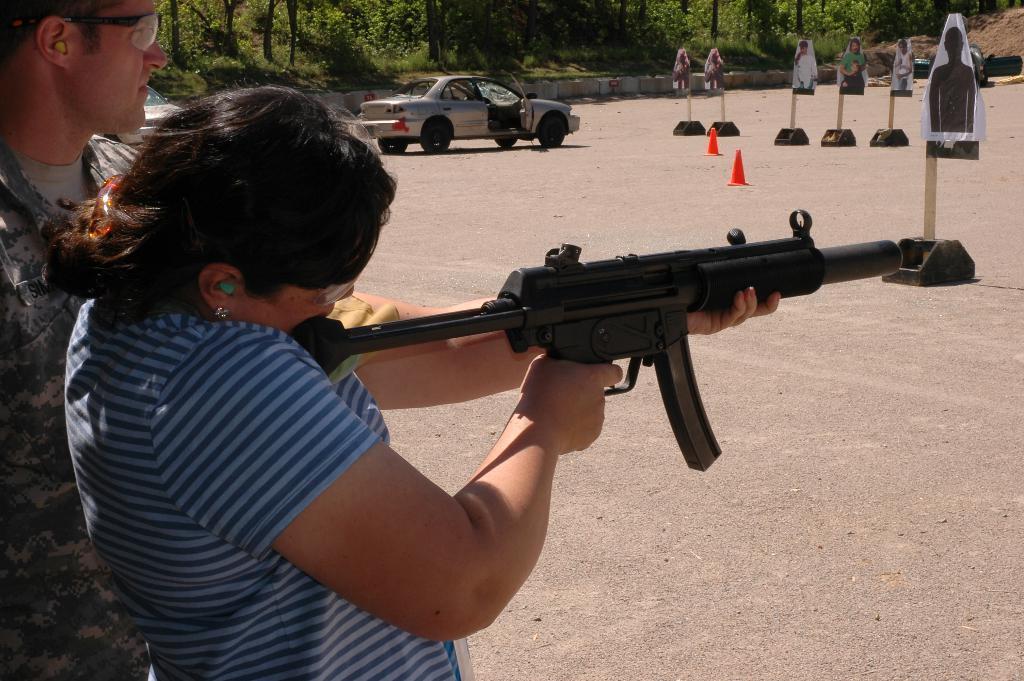Could you give a brief overview of what you see in this image? In this image there is a lady standing and holding a gun in her hand, inside her there is a person standing, in front of them there are a few poles and picture of few persons are attached to it, there are two traffic cones are on the surface and there is a vehicle parked with an open door. In the background there are trees. 